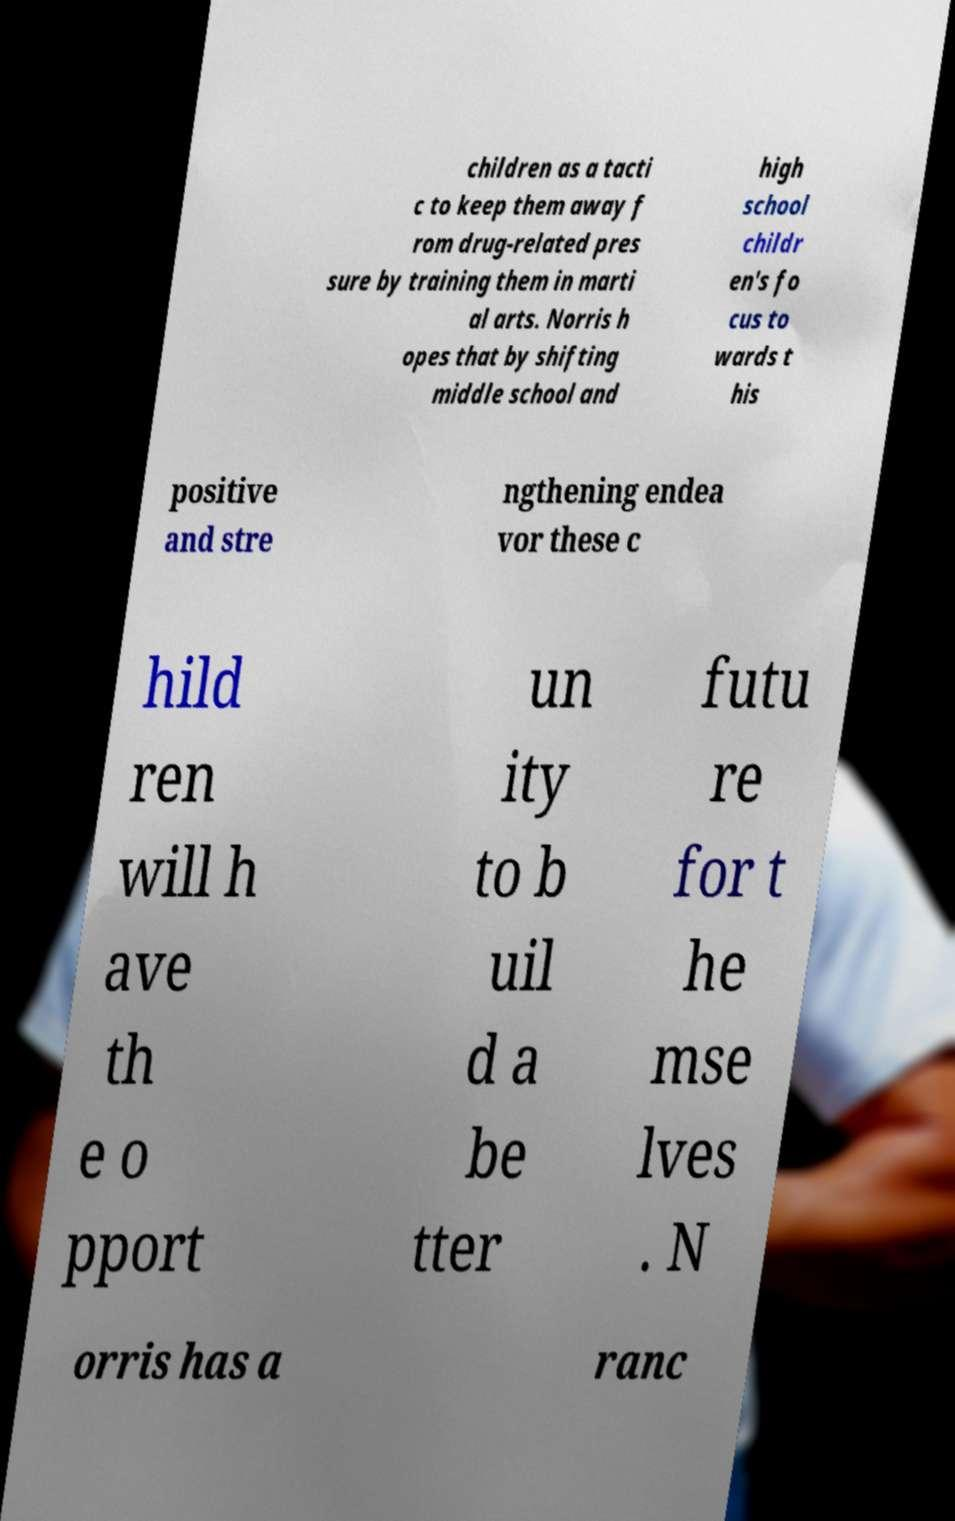Please read and relay the text visible in this image. What does it say? children as a tacti c to keep them away f rom drug-related pres sure by training them in marti al arts. Norris h opes that by shifting middle school and high school childr en's fo cus to wards t his positive and stre ngthening endea vor these c hild ren will h ave th e o pport un ity to b uil d a be tter futu re for t he mse lves . N orris has a ranc 